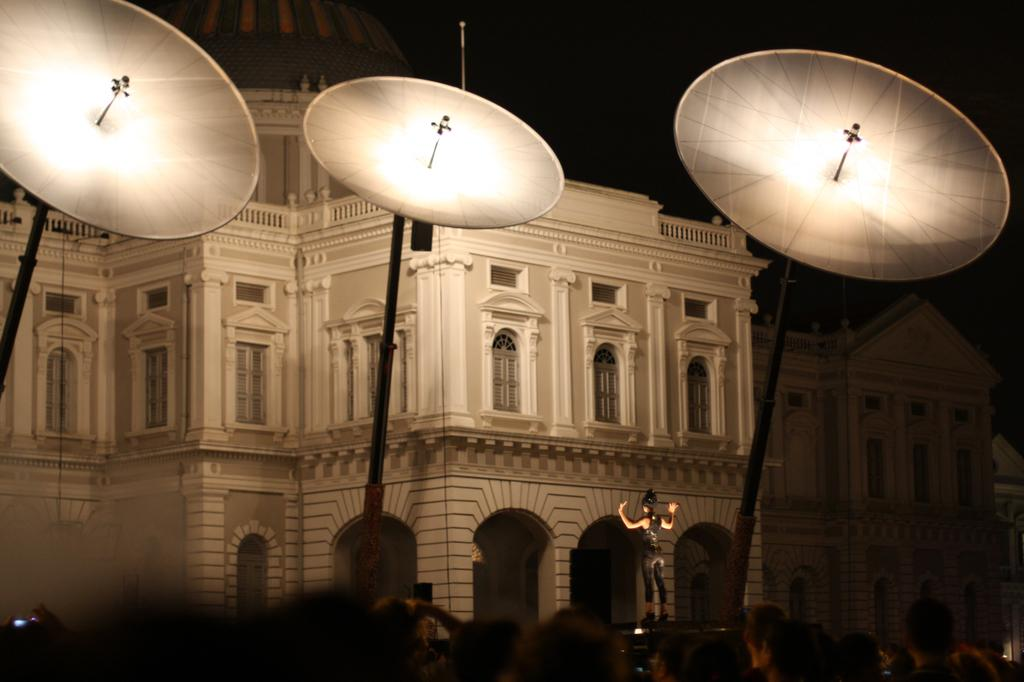What type of building can be seen in the background of the image? There is a palace in the background of the image. Who or what is located at the bottom of the image? There are people at the bottom of the image. What can be found in the center of the image? There are light poles in the center of the image. What is the average income of the people in the image? There is no information about the income of the people in the image. What nation are the people in the image from? There is no information about the nationality of the people in the image. 